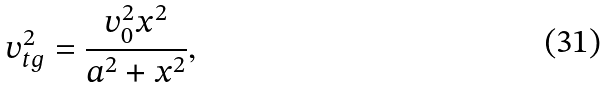<formula> <loc_0><loc_0><loc_500><loc_500>v _ { t g } ^ { 2 } = \frac { v _ { 0 } ^ { 2 } x ^ { 2 } } { a ^ { 2 } + x ^ { 2 } } ,</formula> 